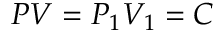<formula> <loc_0><loc_0><loc_500><loc_500>P V = P _ { 1 } V _ { 1 } = C</formula> 